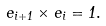Convert formula to latex. <formula><loc_0><loc_0><loc_500><loc_500>e _ { i + 1 } \times e _ { i } = 1 .</formula> 